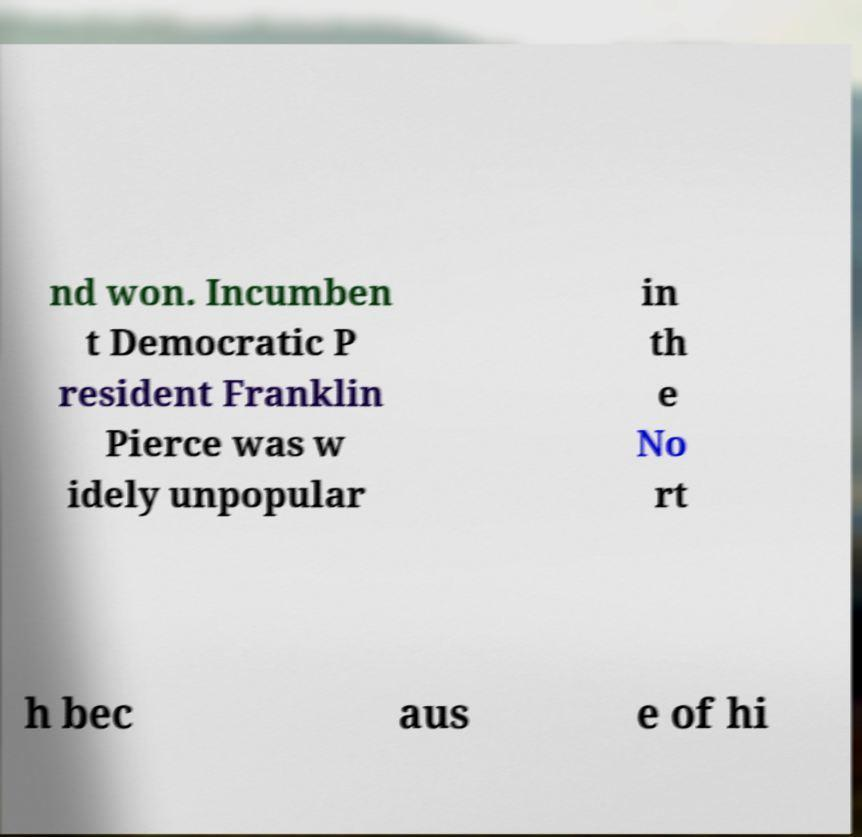Please identify and transcribe the text found in this image. nd won. Incumben t Democratic P resident Franklin Pierce was w idely unpopular in th e No rt h bec aus e of hi 